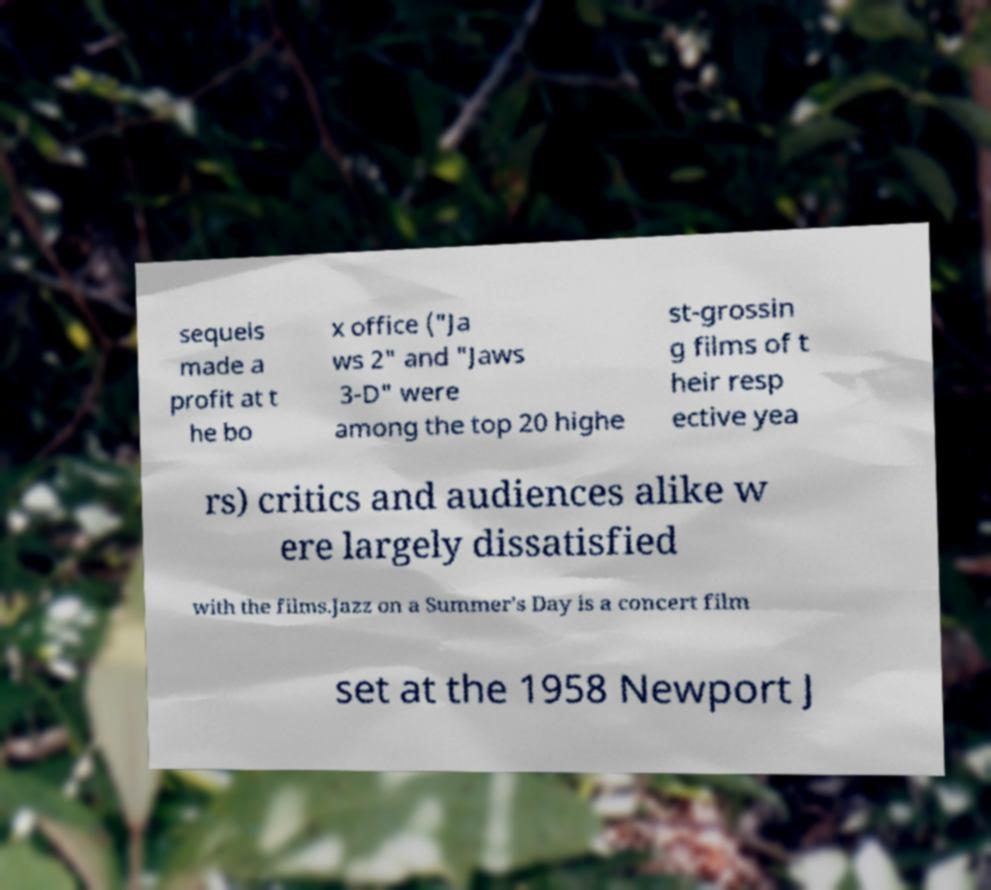What messages or text are displayed in this image? I need them in a readable, typed format. sequels made a profit at t he bo x office ("Ja ws 2" and "Jaws 3-D" were among the top 20 highe st-grossin g films of t heir resp ective yea rs) critics and audiences alike w ere largely dissatisfied with the films.Jazz on a Summer's Day is a concert film set at the 1958 Newport J 